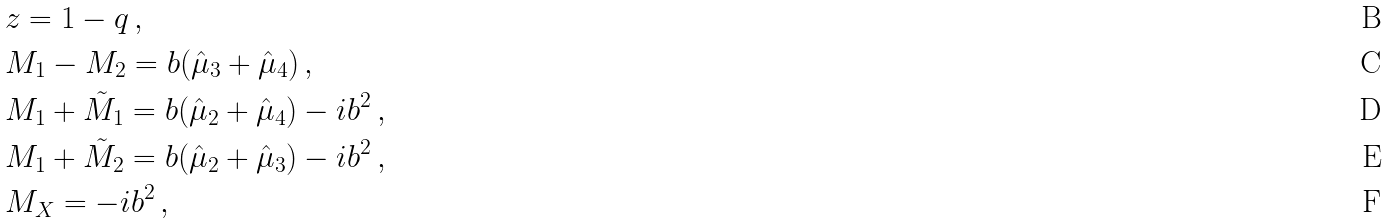<formula> <loc_0><loc_0><loc_500><loc_500>& z = 1 - q \, , \\ & M _ { 1 } - M _ { 2 } = b ( \hat { \mu } _ { 3 } + \hat { \mu } _ { 4 } ) \, , \\ & M _ { 1 } + \tilde { M } _ { 1 } = b ( \hat { \mu } _ { 2 } + \hat { \mu } _ { 4 } ) - i b ^ { 2 } \, , \\ & M _ { 1 } + \tilde { M } _ { 2 } = b ( \hat { \mu } _ { 2 } + \hat { \mu } _ { 3 } ) - i b ^ { 2 } \, , \\ & M _ { X } = - i b ^ { 2 } \, ,</formula> 